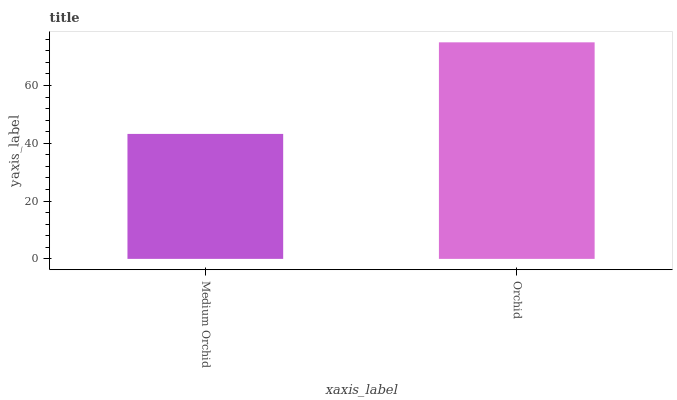Is Medium Orchid the minimum?
Answer yes or no. Yes. Is Orchid the maximum?
Answer yes or no. Yes. Is Orchid the minimum?
Answer yes or no. No. Is Orchid greater than Medium Orchid?
Answer yes or no. Yes. Is Medium Orchid less than Orchid?
Answer yes or no. Yes. Is Medium Orchid greater than Orchid?
Answer yes or no. No. Is Orchid less than Medium Orchid?
Answer yes or no. No. Is Orchid the high median?
Answer yes or no. Yes. Is Medium Orchid the low median?
Answer yes or no. Yes. Is Medium Orchid the high median?
Answer yes or no. No. Is Orchid the low median?
Answer yes or no. No. 